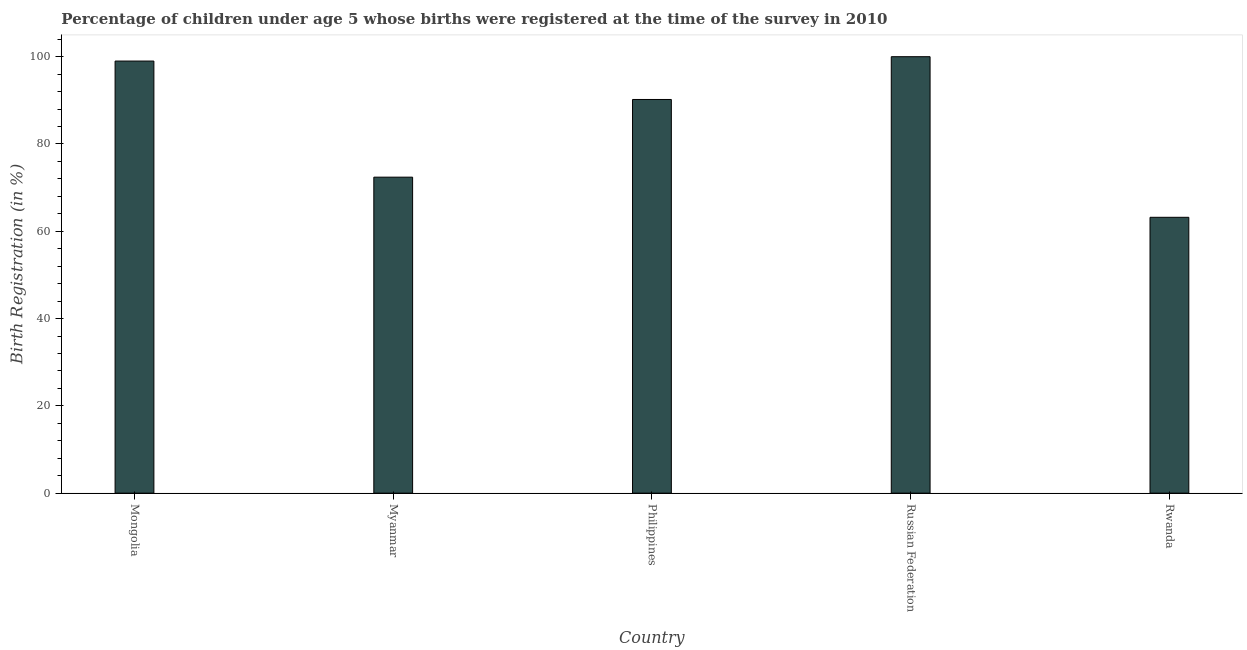Does the graph contain any zero values?
Keep it short and to the point. No. What is the title of the graph?
Keep it short and to the point. Percentage of children under age 5 whose births were registered at the time of the survey in 2010. What is the label or title of the X-axis?
Provide a short and direct response. Country. What is the label or title of the Y-axis?
Provide a short and direct response. Birth Registration (in %). What is the birth registration in Russian Federation?
Ensure brevity in your answer.  100. Across all countries, what is the minimum birth registration?
Ensure brevity in your answer.  63.2. In which country was the birth registration maximum?
Provide a succinct answer. Russian Federation. In which country was the birth registration minimum?
Give a very brief answer. Rwanda. What is the sum of the birth registration?
Keep it short and to the point. 424.8. What is the difference between the birth registration in Philippines and Russian Federation?
Your response must be concise. -9.8. What is the average birth registration per country?
Ensure brevity in your answer.  84.96. What is the median birth registration?
Make the answer very short. 90.2. What is the ratio of the birth registration in Mongolia to that in Myanmar?
Provide a succinct answer. 1.37. What is the difference between the highest and the second highest birth registration?
Your response must be concise. 1. What is the difference between the highest and the lowest birth registration?
Keep it short and to the point. 36.8. Are all the bars in the graph horizontal?
Your response must be concise. No. Are the values on the major ticks of Y-axis written in scientific E-notation?
Provide a short and direct response. No. What is the Birth Registration (in %) in Mongolia?
Make the answer very short. 99. What is the Birth Registration (in %) in Myanmar?
Keep it short and to the point. 72.4. What is the Birth Registration (in %) of Philippines?
Offer a very short reply. 90.2. What is the Birth Registration (in %) of Rwanda?
Your response must be concise. 63.2. What is the difference between the Birth Registration (in %) in Mongolia and Myanmar?
Ensure brevity in your answer.  26.6. What is the difference between the Birth Registration (in %) in Mongolia and Russian Federation?
Provide a succinct answer. -1. What is the difference between the Birth Registration (in %) in Mongolia and Rwanda?
Offer a very short reply. 35.8. What is the difference between the Birth Registration (in %) in Myanmar and Philippines?
Offer a terse response. -17.8. What is the difference between the Birth Registration (in %) in Myanmar and Russian Federation?
Keep it short and to the point. -27.6. What is the difference between the Birth Registration (in %) in Russian Federation and Rwanda?
Give a very brief answer. 36.8. What is the ratio of the Birth Registration (in %) in Mongolia to that in Myanmar?
Your answer should be compact. 1.37. What is the ratio of the Birth Registration (in %) in Mongolia to that in Philippines?
Provide a succinct answer. 1.1. What is the ratio of the Birth Registration (in %) in Mongolia to that in Russian Federation?
Make the answer very short. 0.99. What is the ratio of the Birth Registration (in %) in Mongolia to that in Rwanda?
Your answer should be very brief. 1.57. What is the ratio of the Birth Registration (in %) in Myanmar to that in Philippines?
Your answer should be compact. 0.8. What is the ratio of the Birth Registration (in %) in Myanmar to that in Russian Federation?
Make the answer very short. 0.72. What is the ratio of the Birth Registration (in %) in Myanmar to that in Rwanda?
Keep it short and to the point. 1.15. What is the ratio of the Birth Registration (in %) in Philippines to that in Russian Federation?
Offer a very short reply. 0.9. What is the ratio of the Birth Registration (in %) in Philippines to that in Rwanda?
Your response must be concise. 1.43. What is the ratio of the Birth Registration (in %) in Russian Federation to that in Rwanda?
Your answer should be very brief. 1.58. 